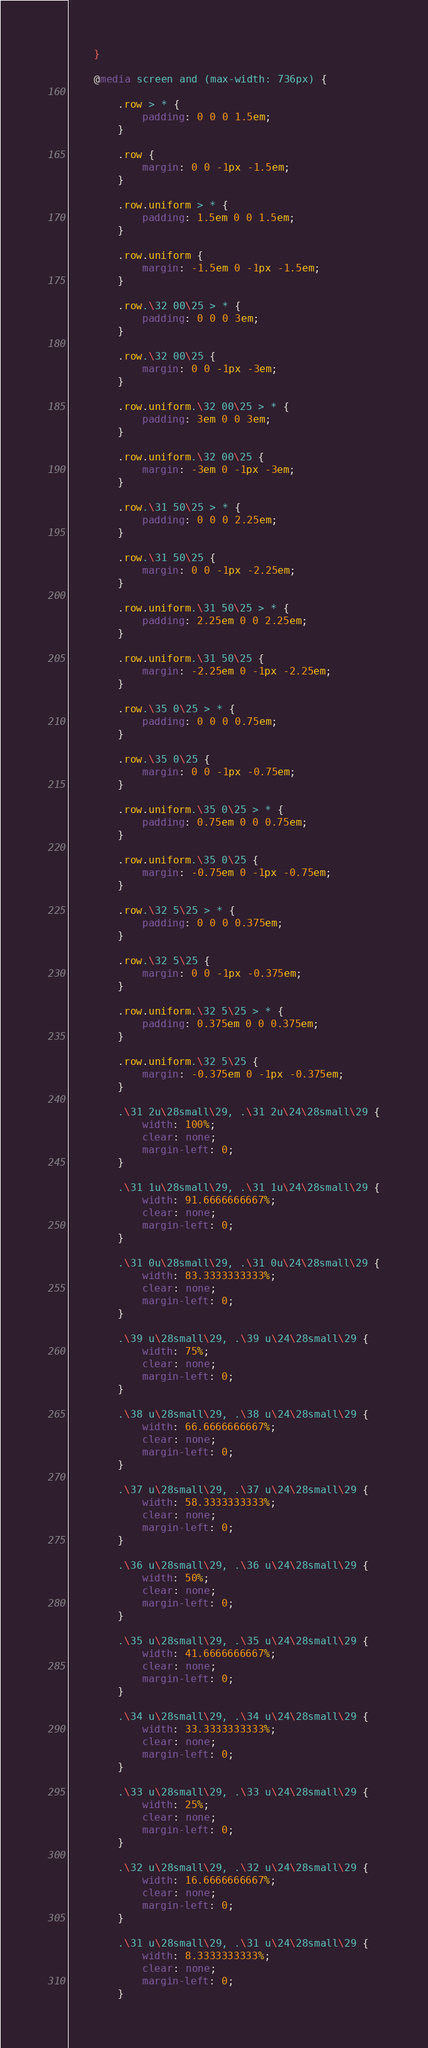<code> <loc_0><loc_0><loc_500><loc_500><_CSS_>	}

	@media screen and (max-width: 736px) {

		.row > * {
			padding: 0 0 0 1.5em;
		}

		.row {
			margin: 0 0 -1px -1.5em;
		}

		.row.uniform > * {
			padding: 1.5em 0 0 1.5em;
		}

		.row.uniform {
			margin: -1.5em 0 -1px -1.5em;
		}

		.row.\32 00\25 > * {
			padding: 0 0 0 3em;
		}

		.row.\32 00\25 {
			margin: 0 0 -1px -3em;
		}

		.row.uniform.\32 00\25 > * {
			padding: 3em 0 0 3em;
		}

		.row.uniform.\32 00\25 {
			margin: -3em 0 -1px -3em;
		}

		.row.\31 50\25 > * {
			padding: 0 0 0 2.25em;
		}

		.row.\31 50\25 {
			margin: 0 0 -1px -2.25em;
		}

		.row.uniform.\31 50\25 > * {
			padding: 2.25em 0 0 2.25em;
		}

		.row.uniform.\31 50\25 {
			margin: -2.25em 0 -1px -2.25em;
		}

		.row.\35 0\25 > * {
			padding: 0 0 0 0.75em;
		}

		.row.\35 0\25 {
			margin: 0 0 -1px -0.75em;
		}

		.row.uniform.\35 0\25 > * {
			padding: 0.75em 0 0 0.75em;
		}

		.row.uniform.\35 0\25 {
			margin: -0.75em 0 -1px -0.75em;
		}

		.row.\32 5\25 > * {
			padding: 0 0 0 0.375em;
		}

		.row.\32 5\25 {
			margin: 0 0 -1px -0.375em;
		}

		.row.uniform.\32 5\25 > * {
			padding: 0.375em 0 0 0.375em;
		}

		.row.uniform.\32 5\25 {
			margin: -0.375em 0 -1px -0.375em;
		}

		.\31 2u\28small\29, .\31 2u\24\28small\29 {
			width: 100%;
			clear: none;
			margin-left: 0;
		}

		.\31 1u\28small\29, .\31 1u\24\28small\29 {
			width: 91.6666666667%;
			clear: none;
			margin-left: 0;
		}

		.\31 0u\28small\29, .\31 0u\24\28small\29 {
			width: 83.3333333333%;
			clear: none;
			margin-left: 0;
		}

		.\39 u\28small\29, .\39 u\24\28small\29 {
			width: 75%;
			clear: none;
			margin-left: 0;
		}

		.\38 u\28small\29, .\38 u\24\28small\29 {
			width: 66.6666666667%;
			clear: none;
			margin-left: 0;
		}

		.\37 u\28small\29, .\37 u\24\28small\29 {
			width: 58.3333333333%;
			clear: none;
			margin-left: 0;
		}

		.\36 u\28small\29, .\36 u\24\28small\29 {
			width: 50%;
			clear: none;
			margin-left: 0;
		}

		.\35 u\28small\29, .\35 u\24\28small\29 {
			width: 41.6666666667%;
			clear: none;
			margin-left: 0;
		}

		.\34 u\28small\29, .\34 u\24\28small\29 {
			width: 33.3333333333%;
			clear: none;
			margin-left: 0;
		}

		.\33 u\28small\29, .\33 u\24\28small\29 {
			width: 25%;
			clear: none;
			margin-left: 0;
		}

		.\32 u\28small\29, .\32 u\24\28small\29 {
			width: 16.6666666667%;
			clear: none;
			margin-left: 0;
		}

		.\31 u\28small\29, .\31 u\24\28small\29 {
			width: 8.3333333333%;
			clear: none;
			margin-left: 0;
		}
</code> 